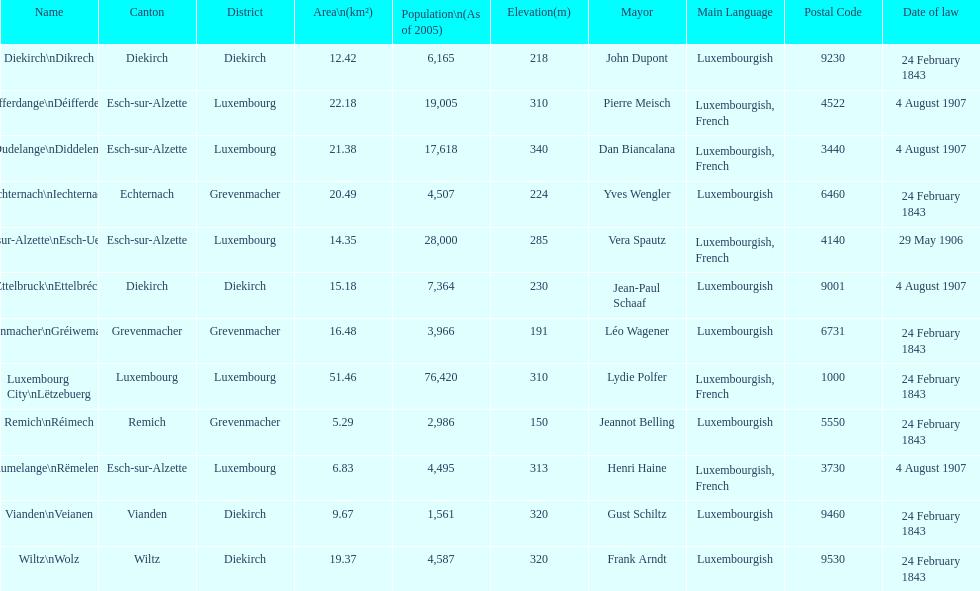Parse the table in full. {'header': ['Name', 'Canton', 'District', 'Area\\n(km²)', 'Population\\n(As of 2005)', 'Elevation(m)', 'Mayor', 'Main Language', 'Postal Code', 'Date of law'], 'rows': [['Diekirch\\nDikrech', 'Diekirch', 'Diekirch', '12.42', '6,165', '218', 'John Dupont', 'Luxembourgish', '9230', '24 February 1843'], ['Differdange\\nDéifferdeng', 'Esch-sur-Alzette', 'Luxembourg', '22.18', '19,005', '310', 'Pierre Meisch', 'Luxembourgish, French', '4522', '4 August 1907'], ['Dudelange\\nDiddeleng', 'Esch-sur-Alzette', 'Luxembourg', '21.38', '17,618', '340', 'Dan Biancalana', 'Luxembourgish, French', '3440', '4 August 1907'], ['Echternach\\nIechternach', 'Echternach', 'Grevenmacher', '20.49', '4,507', '224', 'Yves Wengler', 'Luxembourgish', '6460', '24 February 1843'], ['Esch-sur-Alzette\\nEsch-Uelzecht', 'Esch-sur-Alzette', 'Luxembourg', '14.35', '28,000', '285', 'Vera Spautz', 'Luxembourgish, French', '4140', '29 May 1906'], ['Ettelbruck\\nEttelbréck', 'Diekirch', 'Diekirch', '15.18', '7,364', '230', 'Jean-Paul Schaaf', 'Luxembourgish', '9001', '4 August 1907'], ['Grevenmacher\\nGréiwemaacher', 'Grevenmacher', 'Grevenmacher', '16.48', '3,966', '191', 'Léo Wagener', 'Luxembourgish', '6731', '24 February 1843'], ['Luxembourg City\\nLëtzebuerg', 'Luxembourg', 'Luxembourg', '51.46', '76,420', '310', 'Lydie Polfer', 'Luxembourgish, French', '1000', '24 February 1843'], ['Remich\\nRéimech', 'Remich', 'Grevenmacher', '5.29', '2,986', '150', 'Jeannot Belling', 'Luxembourgish', '5550', '24 February 1843'], ['Rumelange\\nRëmeleng', 'Esch-sur-Alzette', 'Luxembourg', '6.83', '4,495', '313', 'Henri Haine', 'Luxembourgish, French', '3730', '4 August 1907'], ['Vianden\\nVeianen', 'Vianden', 'Diekirch', '9.67', '1,561', '320', 'Gust Schiltz', 'Luxembourgish', '9460', '24 February 1843'], ['Wiltz\\nWolz', 'Wiltz', 'Diekirch', '19.37', '4,587', '320', 'Frank Arndt', 'Luxembourgish', '9530', '24 February 1843']]} Which canton falls under the date of law of 24 february 1843 and has a population of 3,966? Grevenmacher. 